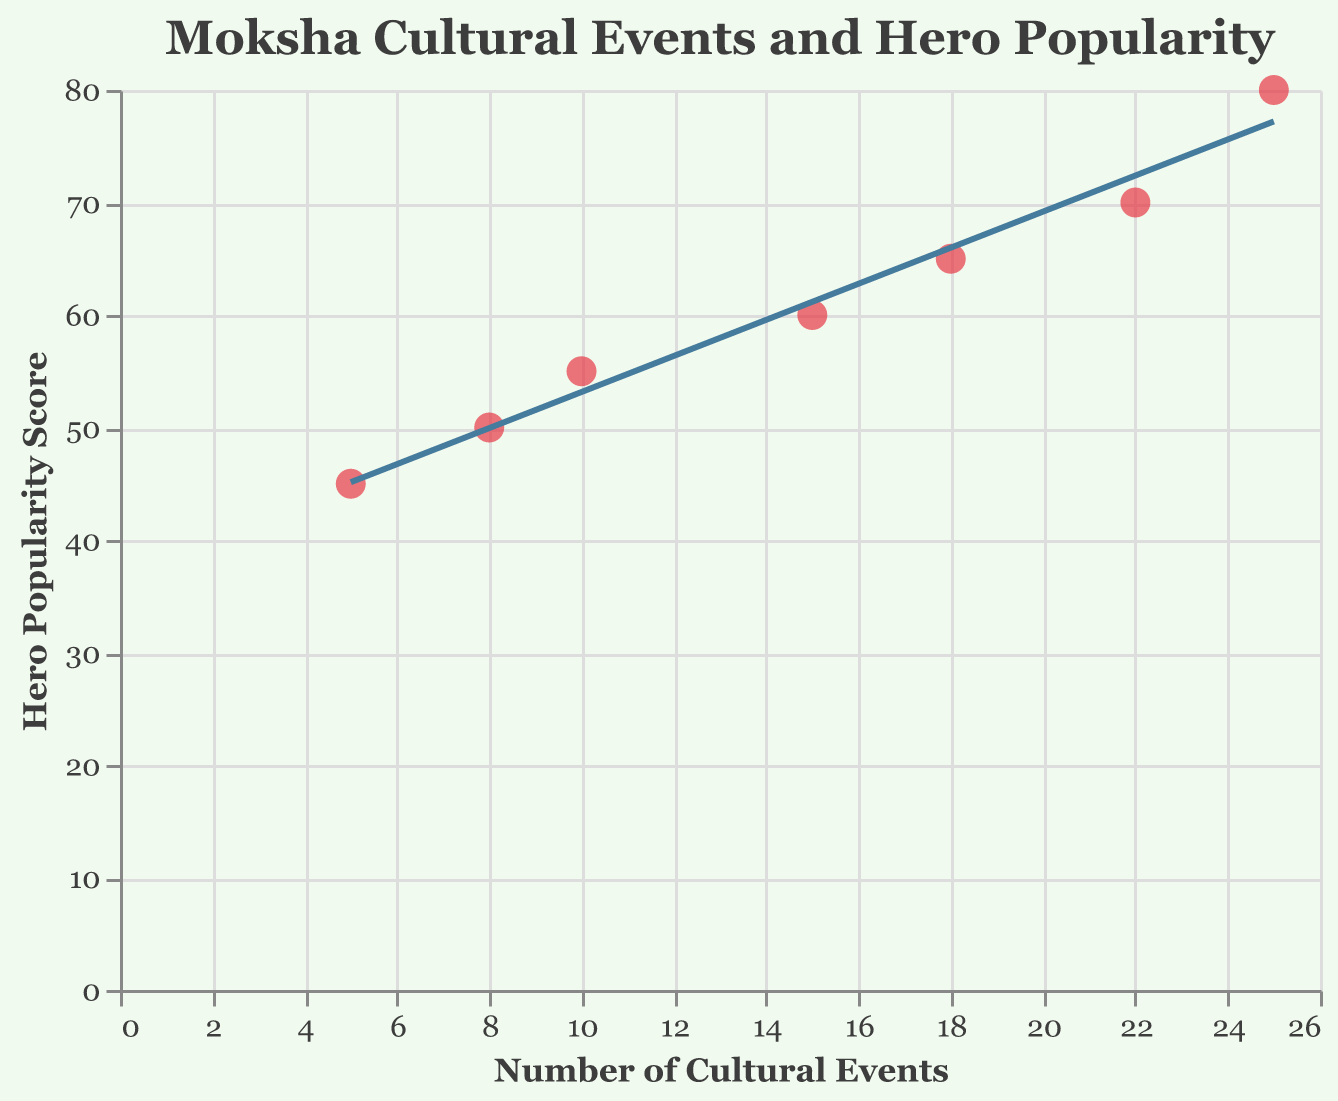What is the title of the plot? The title of the plot is usually prominently displayed at the top of the figure. For this figure, the title is specified to help viewers understand what the plot is about.
Answer: Moksha Cultural Events and Hero Popularity How many data points are displayed in the plot? Count the number of points in the scatter plot. Each point corresponds to a data record from the table. There are seven records, hence seven points.
Answer: 7 What is the range of the Number of Moksha-themed Cultural Events? Look at the x-axis to identify the smallest and largest values. The smallest value is 5 events from the 1960s, and the largest is 25 events from the 2020s.
Answer: 5 to 25 Which decade had the highest Local Hero Popularity Score? Observe the y-axis values corresponding to each decade's data points. The highest score is from the 2020s with a value of 80.
Answer: 2020s What is the trend shown by the line in the plot? The trend line generally indicates the direction in which the data points are heading. In this case, the rising line suggests an increase in Local Hero Popularity as the Number of Moksha-themed Cultural Events increases.
Answer: Increasing Which decade saw the most significant increase in Local Hero Popularity Score? Compare the differences in the Local Hero Popularity Score between successive decades by looking at the respective y-values. The 2020s saw the most significant increase from 70 (2010s) to 80 (2020s), a change of 10 points.
Answer: 2020s In which decade did the Number of Moksha-themed Cultural Events increase the most compared to the previous decade? To determine this, compare the increase in the number of events between consecutive decades. The increase from the 1980s to the 1990s was the largest, from 10 to 15, an increase of 5 events.
Answer: 1990s Is there a decade with more than 20 Moksha-themed Cultural Events? Look at the x-axis for values exceeding 20 and check which decade(s) correspond to those values. The 2010s and 2020s both have more than 20 events.
Answer: Yes Between which two decades is the trend line steepest? The steepness of the trend line between two points reflects the rate of change. The segment between the 1980s and 1990s appears the steepest because Local Hero Popularity Score increases by 5 with an event increase of 5, giving a slope of 1, which is the highest rate of change visible in the plot.
Answer: 1980s and 1990s 